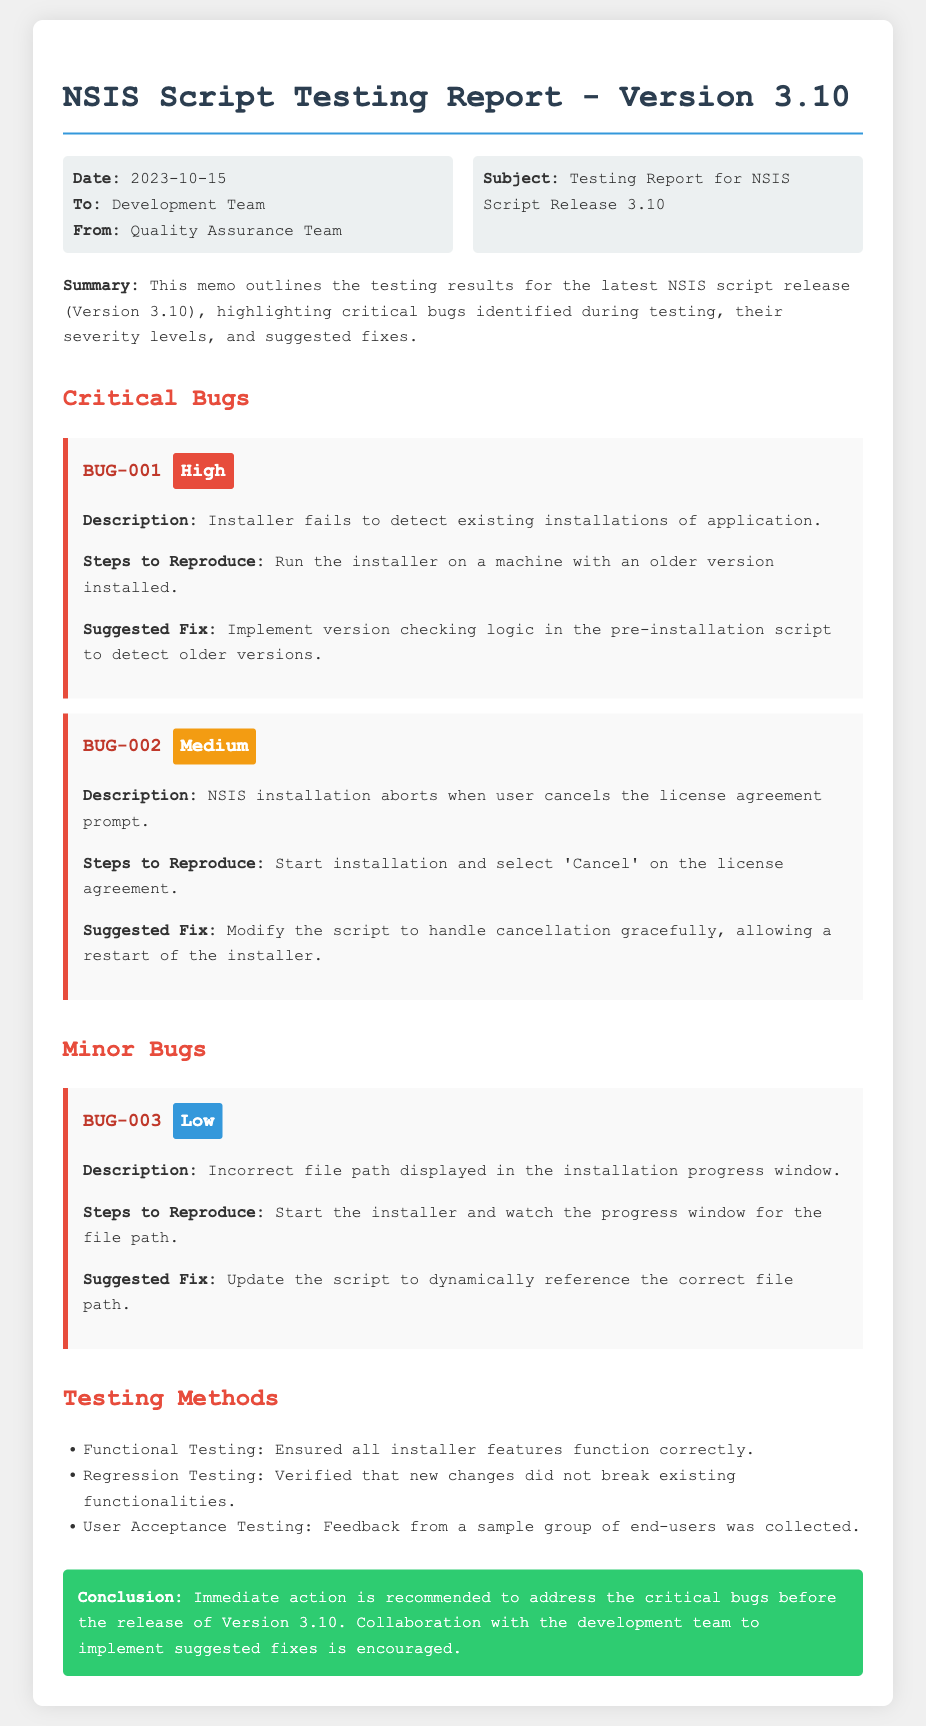What is the version number of the NSIS script? The document states that the testing report is for Version 3.10.
Answer: Version 3.10 When was the testing report issued? The memo indicates that the report was issued on 2023-10-15.
Answer: 2023-10-15 How many critical bugs are reported? The memo lists two critical bugs under the "Critical Bugs" section.
Answer: 2 What is the severity level of BUG-001? The document describes the severity level of BUG-001 as "High."
Answer: High What is the suggested fix for BUG-002? The memo suggests modifying the script to handle cancellation gracefully.
Answer: Modify the script to handle cancellation gracefully What type of testing methods were used? The document enumerates three types of testing methods: Functional Testing, Regression Testing, User Acceptance Testing.
Answer: Functional Testing, Regression Testing, User Acceptance Testing What is the conclusion regarding the critical bugs? The conclusion recommends immediate action to address the critical bugs before the release.
Answer: Immediate action is recommended What color is used for low severity bugs? The document specifically describes low severity bugs with the color blue in the severity section.
Answer: Blue 